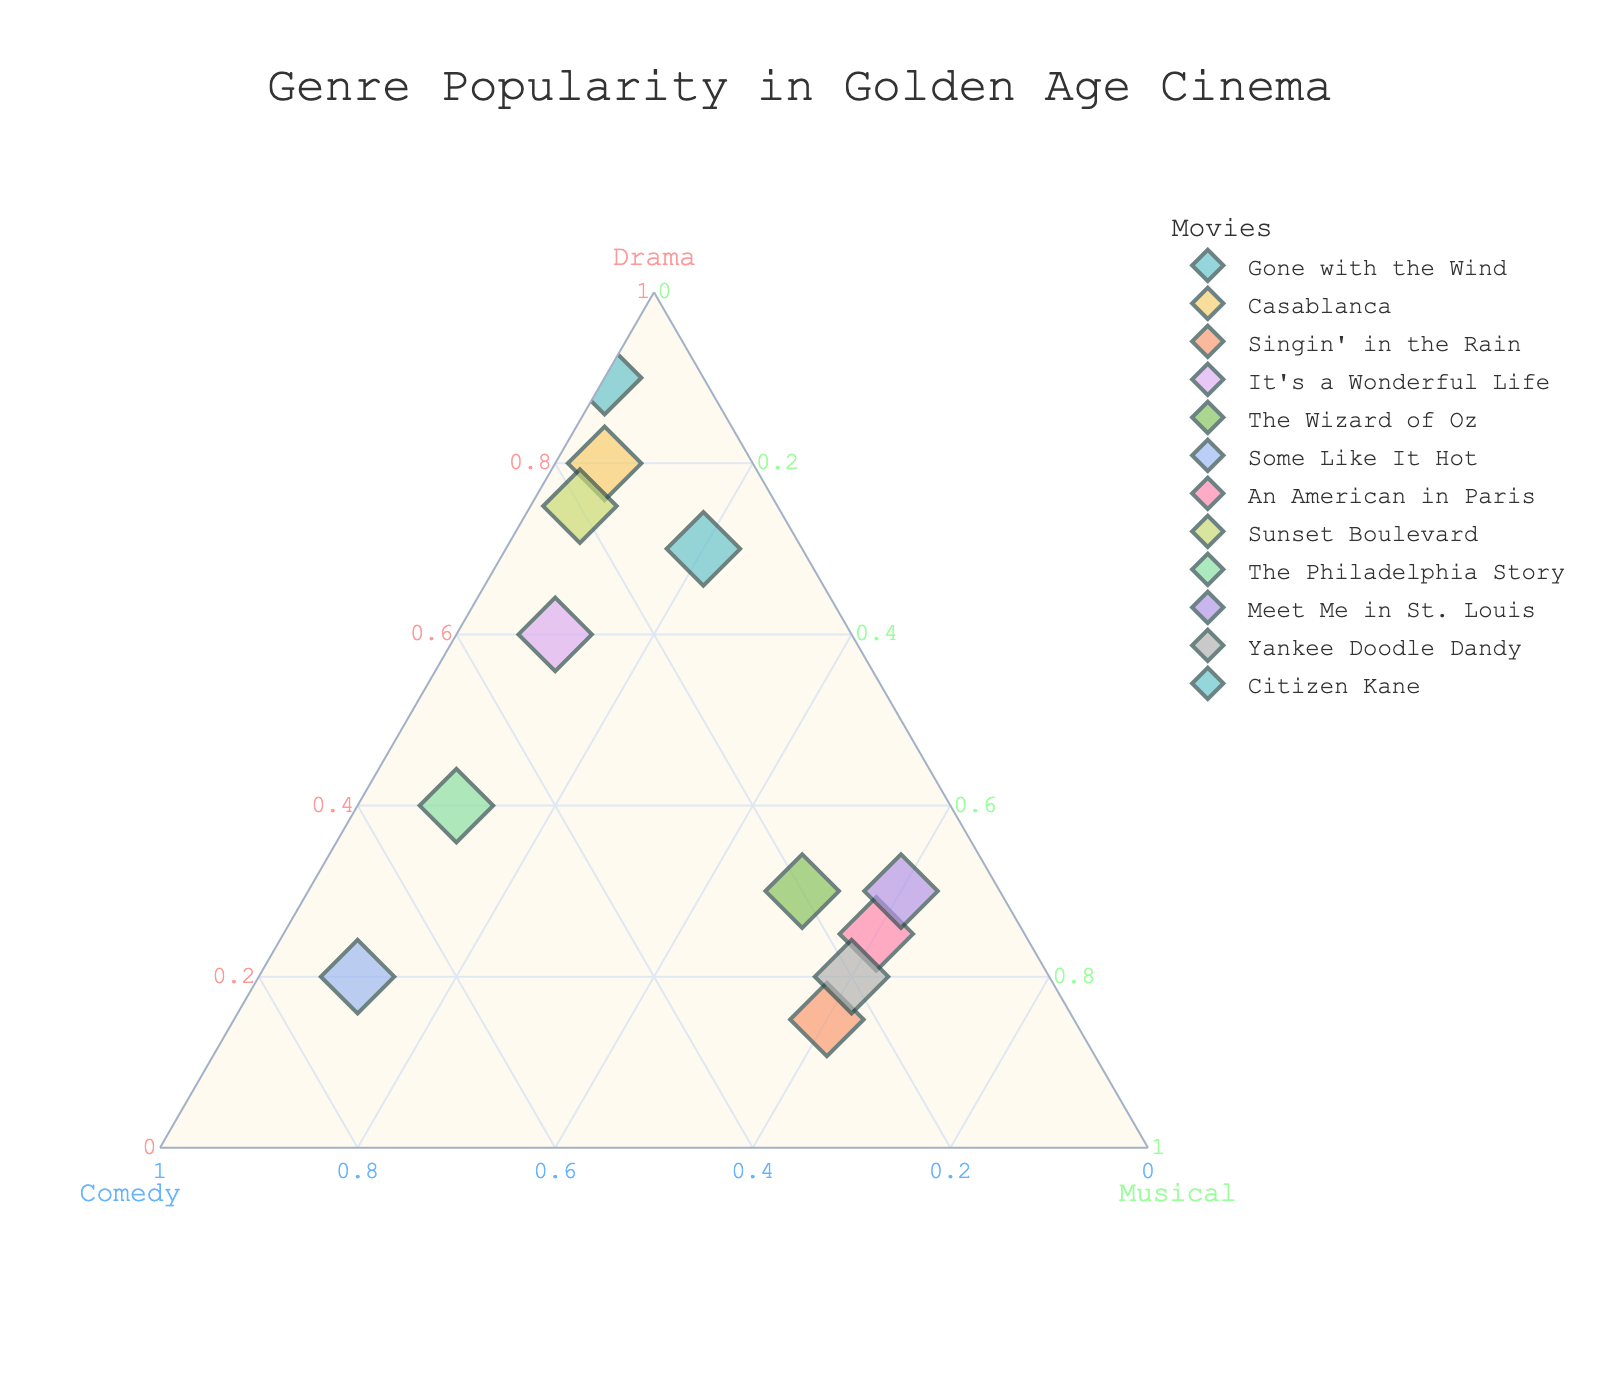What's the title of the plot? The title is displayed at the top center of the plot in a larger font size, making it easy to identify.
Answer: "Genre Popularity in Golden Age Cinema" How many movies are analyzed in the plot? By counting the unique markers or data points plotted on the graph, each representing a different movie.
Answer: 12 Which movie has the highest Drama component? To determine this, look for the point that is closest to the Drama axis, which is represented by the clear titles and legends.
Answer: "Citizen Kane" How do the compositions of "Some Like It Hot" and "Singin' in the Rain" compare in terms of Comedy? Examining the ternary plot, each movie’s position will indicate its genre composition. "Some Like It Hot" has a Comedy value of 0.70, while "Singin' in the Rain" has a Comedy value of 0.25.
Answer: "Some Like It Hot" has more Comedy component than "Singin' in the Rain" Which movie is positioned closest to having equal parts Drama, Comedy, and Musical? Look for the point nearest to the center of the ternary plot, symbolizing near-equal components.
Answer: "The Philadelphia Story" What is the sum of Drama and Comedy components in "Gone with the Wind"? Refer to the coordinates given for "Gone with the Wind": Drama (0.70) and Comedy (0.10). Adding these two values together gives the total.
Answer: 0.80 Which three movies have the highest Musical component? Check for the points furthest from the Musical axis and identify the movies "Singin' in the Rain", "Meet Me in St. Louis", and "Yankee Doodle Dandy" having higher values close to 0.60.
Answer: "Singin' in the Rain", "Meet Me in St. Louis", "Yankee Doodle Dandy" How does "An American in Paris" compare to "The Wizard of Oz" in their Musical components? Position analysis on the ternary plot shows "An American in Paris" and "The Wizard of Oz" with equal Musical values of 0.60 and 0.50 respectively.
Answer: "An American in Paris" has more Musical component than "The Wizard of Oz" Which movie has not more than 10% Comedy? Identify the movies positioned closest to the Comedy axis limit: "Gone with the Wind", "Citizen Kane", "Meet Me in St. Louis".
Answer: "Gone with the Wind", "Citizen Kane", "Meet Me in St. Louis" What is the color representing "Casablanca" on the plot? By referring to the color keys and legends, each movie's unique color identifier is clear. "Casablanca" is shown in a distinctive light pastel color.
Answer: Light pastel color 